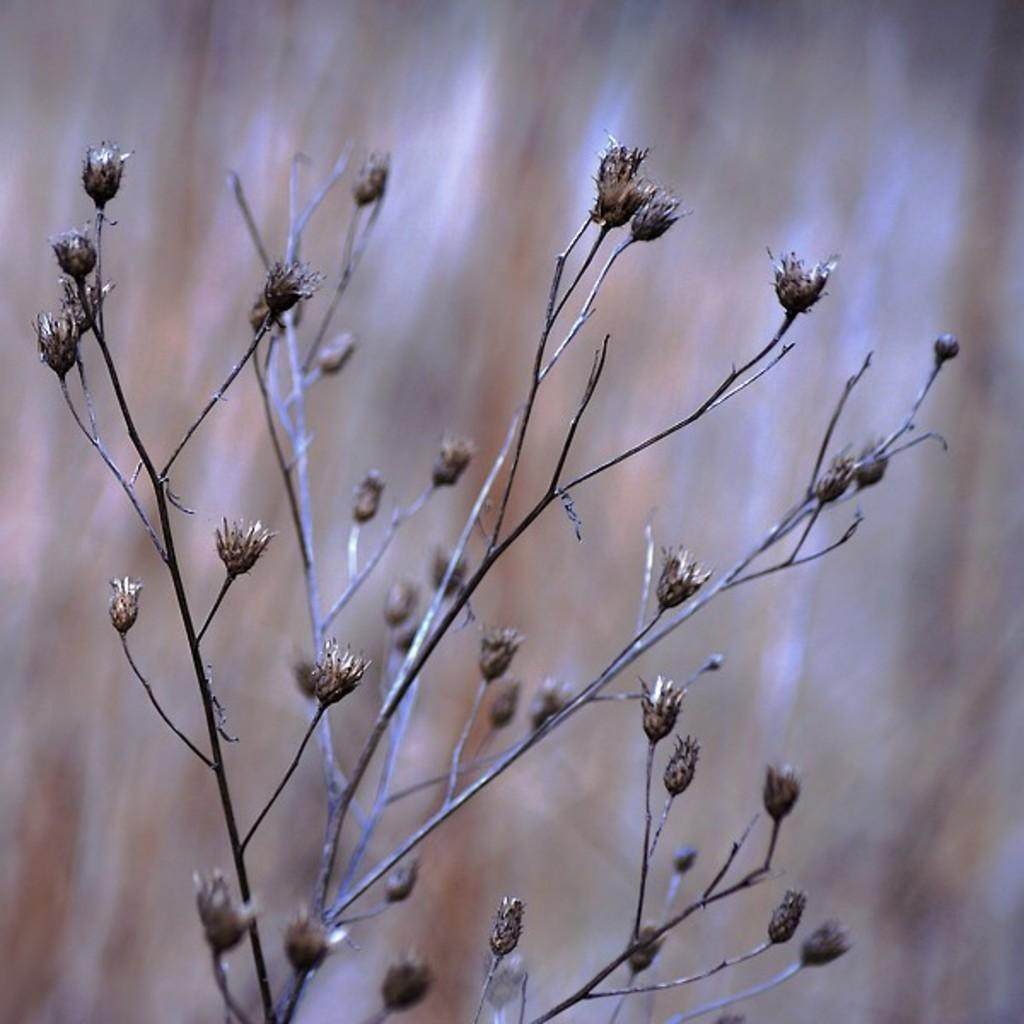What is the main subject in the front of the image? There is a dried plant in the front of the image. Can you describe the background of the image? The background of the image is blurry. What type of cub can be seen playing with a seed in the image? There is no cub or seed present in the image; it only features a dried plant and a blurry background. 